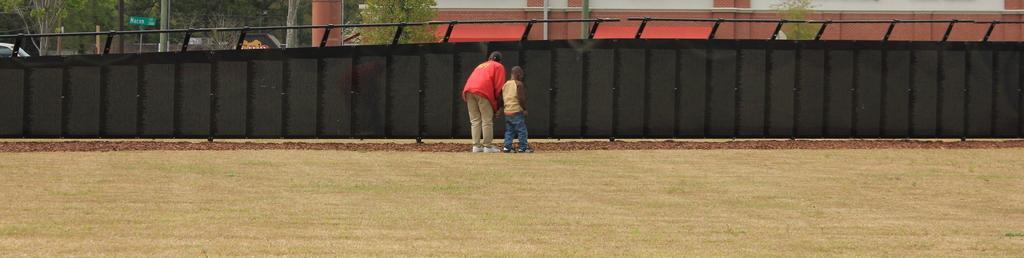Can you describe this image briefly? In this image I can see two persons standing. The person in front wearing red color jacket, cream color pant and the other person wearing brown shirt, blue color pant. Background I can see a building in red color, trees in green color. 